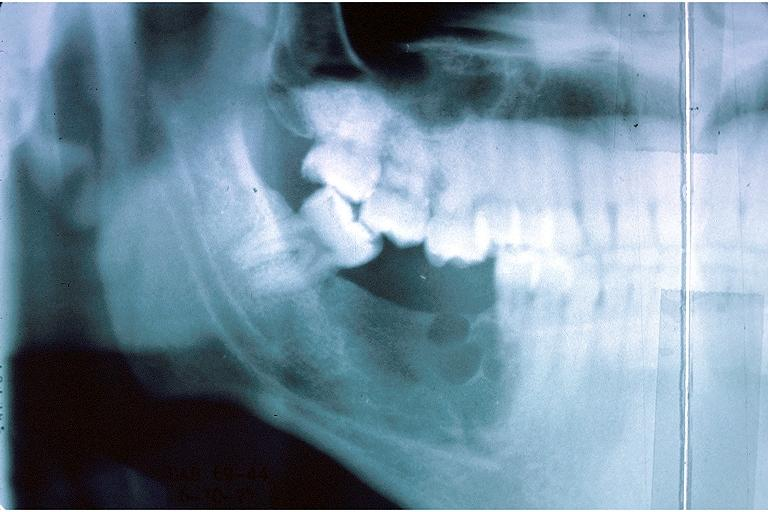s the superior vena cava present?
Answer the question using a single word or phrase. No 